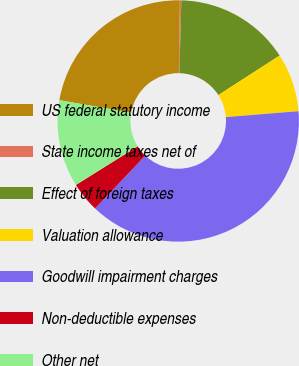<chart> <loc_0><loc_0><loc_500><loc_500><pie_chart><fcel>US federal statutory income<fcel>State income taxes net of<fcel>Effect of foreign taxes<fcel>Valuation allowance<fcel>Goodwill impairment charges<fcel>Non-deductible expenses<fcel>Other net<nl><fcel>22.46%<fcel>0.19%<fcel>15.47%<fcel>7.83%<fcel>38.38%<fcel>4.01%<fcel>11.65%<nl></chart> 